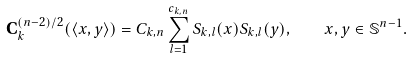Convert formula to latex. <formula><loc_0><loc_0><loc_500><loc_500>\mathbf C _ { k } ^ { ( n - 2 ) / 2 } ( \langle x , y \rangle ) = C _ { k , n } \sum _ { l = 1 } ^ { c _ { k , n } } S _ { k , l } ( x ) S _ { k , l } ( y ) , \quad x , y \in { \mathbb { S } } ^ { n - 1 } .</formula> 